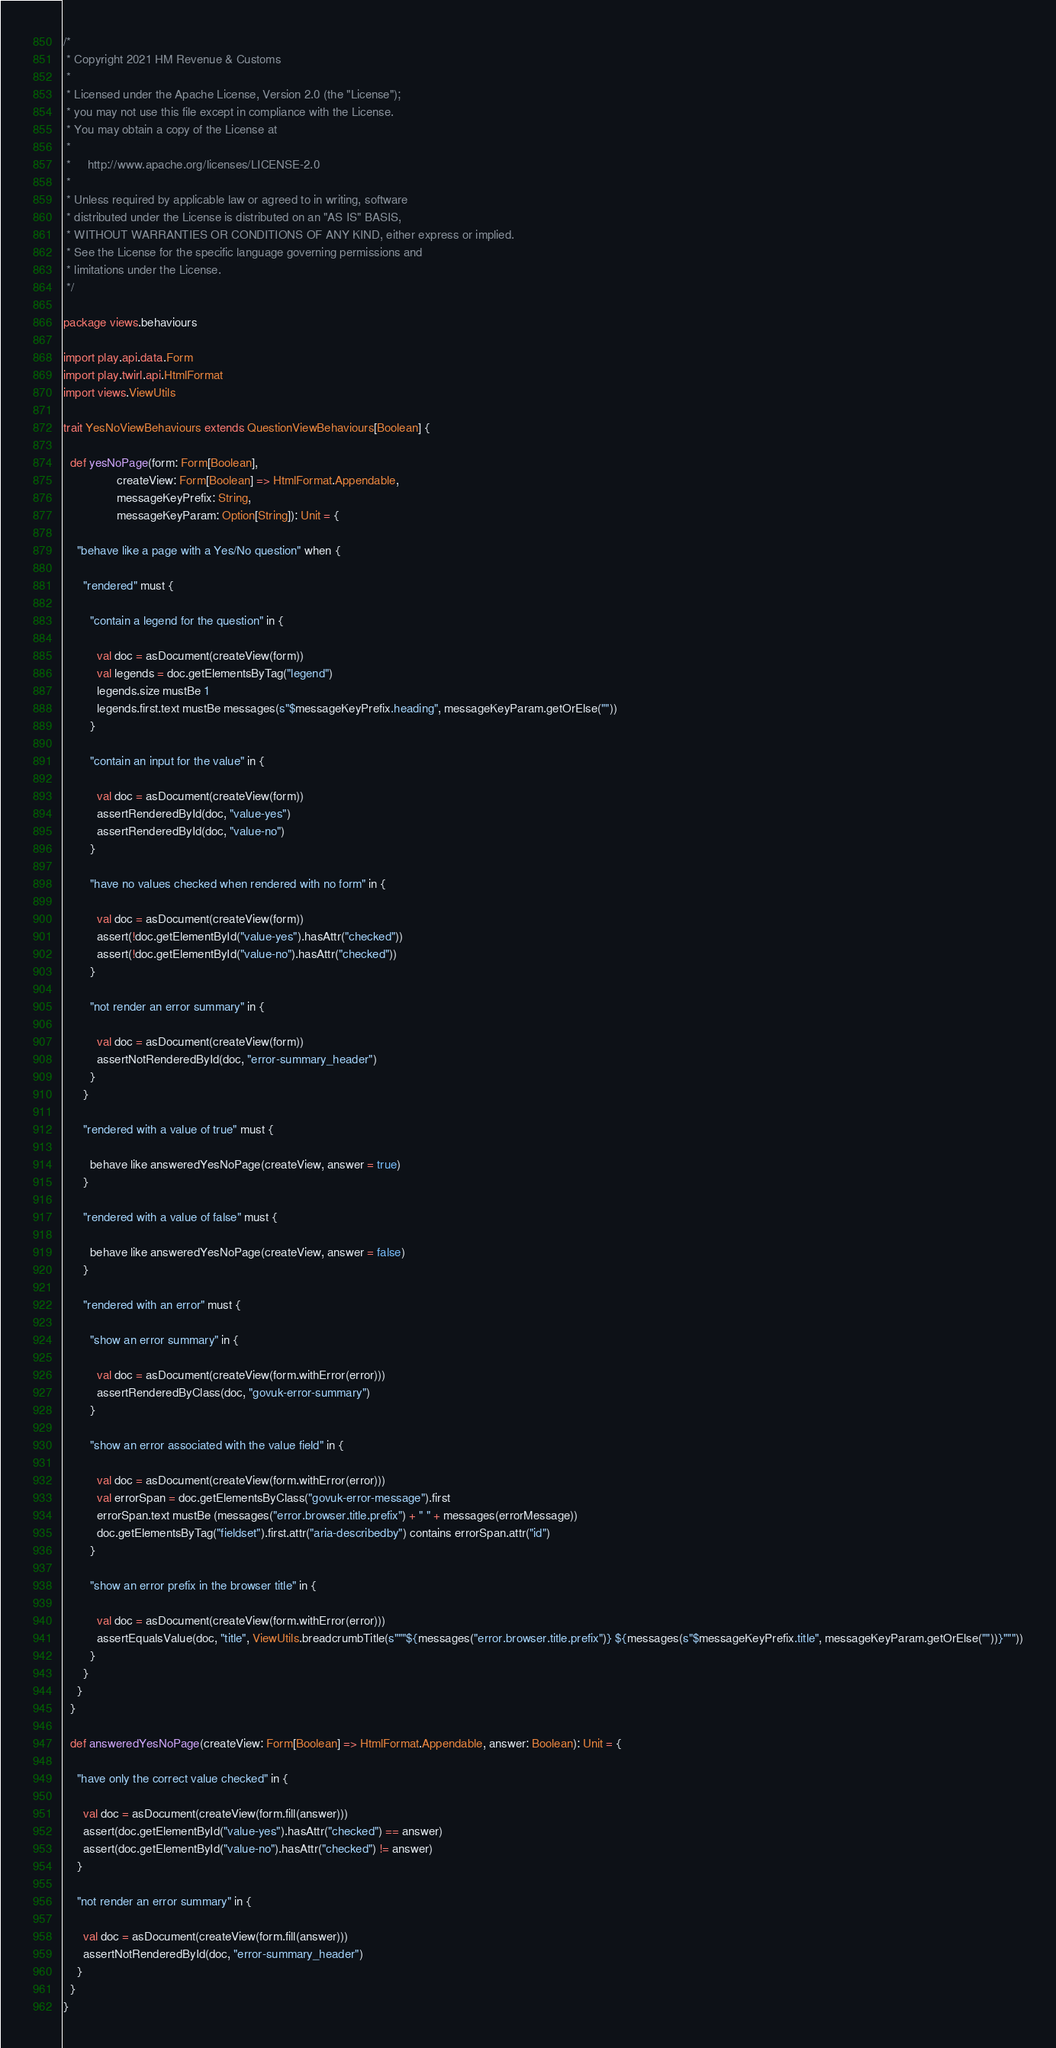Convert code to text. <code><loc_0><loc_0><loc_500><loc_500><_Scala_>/*
 * Copyright 2021 HM Revenue & Customs
 *
 * Licensed under the Apache License, Version 2.0 (the "License");
 * you may not use this file except in compliance with the License.
 * You may obtain a copy of the License at
 *
 *     http://www.apache.org/licenses/LICENSE-2.0
 *
 * Unless required by applicable law or agreed to in writing, software
 * distributed under the License is distributed on an "AS IS" BASIS,
 * WITHOUT WARRANTIES OR CONDITIONS OF ANY KIND, either express or implied.
 * See the License for the specific language governing permissions and
 * limitations under the License.
 */

package views.behaviours

import play.api.data.Form
import play.twirl.api.HtmlFormat
import views.ViewUtils

trait YesNoViewBehaviours extends QuestionViewBehaviours[Boolean] {

  def yesNoPage(form: Form[Boolean],
                createView: Form[Boolean] => HtmlFormat.Appendable,
                messageKeyPrefix: String,
                messageKeyParam: Option[String]): Unit = {

    "behave like a page with a Yes/No question" when {

      "rendered" must {

        "contain a legend for the question" in {

          val doc = asDocument(createView(form))
          val legends = doc.getElementsByTag("legend")
          legends.size mustBe 1
          legends.first.text mustBe messages(s"$messageKeyPrefix.heading", messageKeyParam.getOrElse(""))
        }

        "contain an input for the value" in {

          val doc = asDocument(createView(form))
          assertRenderedById(doc, "value-yes")
          assertRenderedById(doc, "value-no")
        }

        "have no values checked when rendered with no form" in {

          val doc = asDocument(createView(form))
          assert(!doc.getElementById("value-yes").hasAttr("checked"))
          assert(!doc.getElementById("value-no").hasAttr("checked"))
        }

        "not render an error summary" in {

          val doc = asDocument(createView(form))
          assertNotRenderedById(doc, "error-summary_header")
        }
      }

      "rendered with a value of true" must {

        behave like answeredYesNoPage(createView, answer = true)
      }

      "rendered with a value of false" must {

        behave like answeredYesNoPage(createView, answer = false)
      }

      "rendered with an error" must {

        "show an error summary" in {

          val doc = asDocument(createView(form.withError(error)))
          assertRenderedByClass(doc, "govuk-error-summary")
        }

        "show an error associated with the value field" in {

          val doc = asDocument(createView(form.withError(error)))
          val errorSpan = doc.getElementsByClass("govuk-error-message").first
          errorSpan.text mustBe (messages("error.browser.title.prefix") + " " + messages(errorMessage))
          doc.getElementsByTag("fieldset").first.attr("aria-describedby") contains errorSpan.attr("id")
        }

        "show an error prefix in the browser title" in {

          val doc = asDocument(createView(form.withError(error)))
          assertEqualsValue(doc, "title", ViewUtils.breadcrumbTitle(s"""${messages("error.browser.title.prefix")} ${messages(s"$messageKeyPrefix.title", messageKeyParam.getOrElse(""))}"""))
        }
      }
    }
  }

  def answeredYesNoPage(createView: Form[Boolean] => HtmlFormat.Appendable, answer: Boolean): Unit = {

    "have only the correct value checked" in {

      val doc = asDocument(createView(form.fill(answer)))
      assert(doc.getElementById("value-yes").hasAttr("checked") == answer)
      assert(doc.getElementById("value-no").hasAttr("checked") != answer)
    }

    "not render an error summary" in {

      val doc = asDocument(createView(form.fill(answer)))
      assertNotRenderedById(doc, "error-summary_header")
    }
  }
}
</code> 